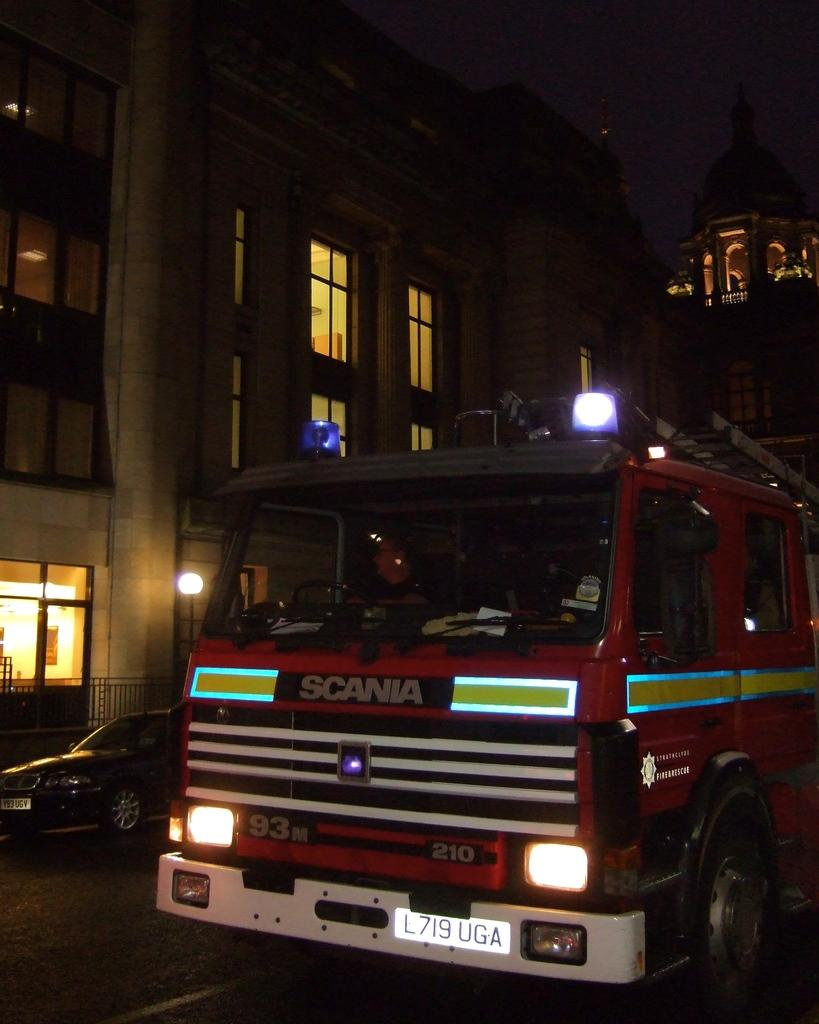What can be seen on the road in the image? There are vehicles with lights on the road. What is visible in the background of the image? There are buildings and a lamp post in the background. How would you describe the sky in the image? The sky is dark in the image. What type of floor can be seen in the image? There is no floor visible in the image, as it is an outdoor scene with a road and background elements. What is the scale of the lamp post in the image? The scale of the lamp post cannot be determined from the image alone, as there is no reference point for comparison. 